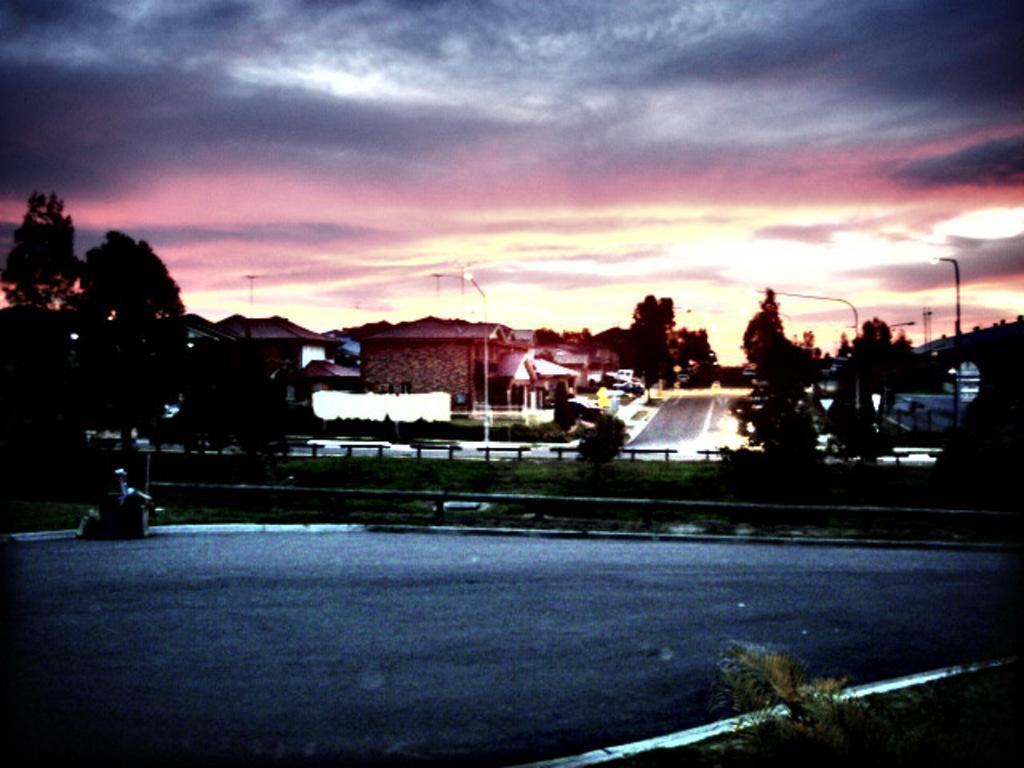Please provide a concise description of this image. In this image I can see few buildings, trees, light poles, poles, road, sky and few objects in front. 